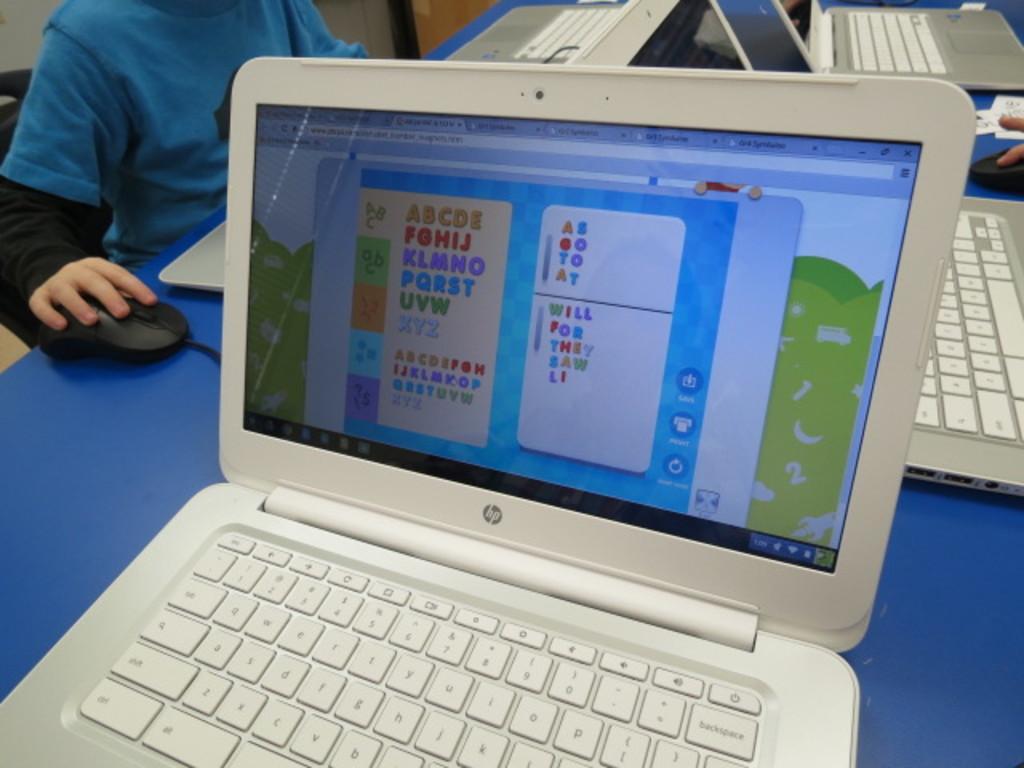I wonder what make/type is that laptop?
Provide a short and direct response. Hp. Is this a computer game for children?
Provide a short and direct response. Yes. 